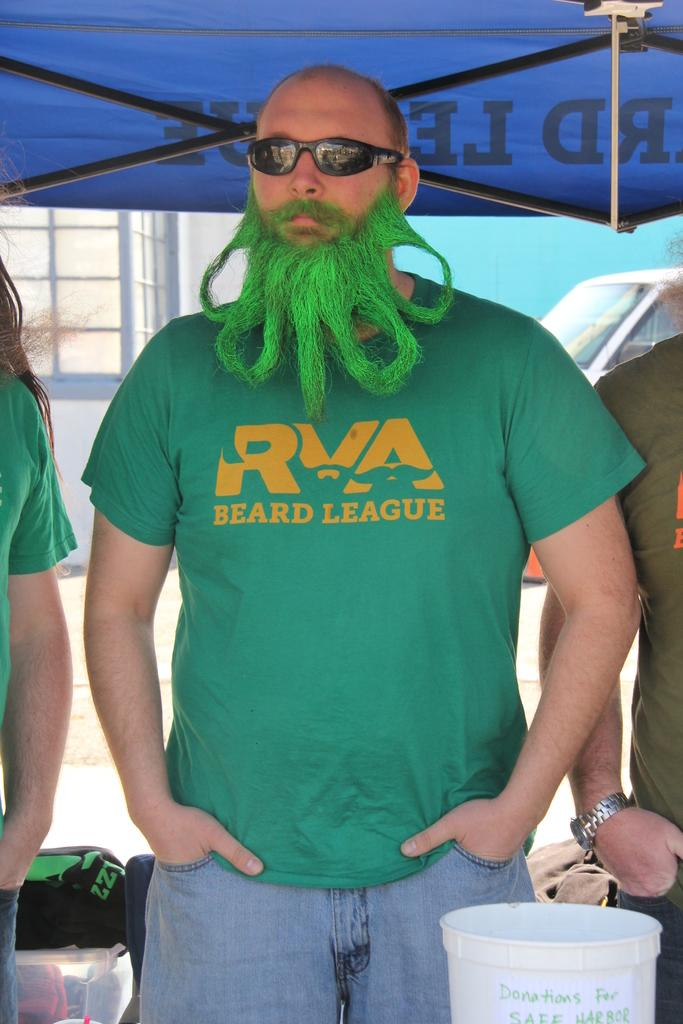Provide a one-sentence caption for the provided image. A man with a green beard and a green shirt that reads, "RVA Beard League". 